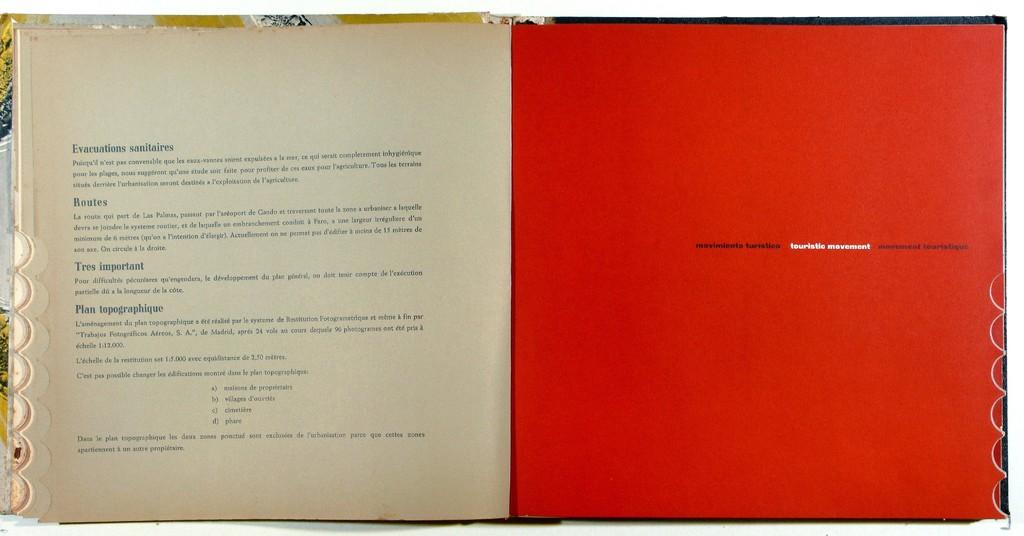<image>
Share a concise interpretation of the image provided. Moviemiento furisticoand touristic movement book about routes and evacuations sanitaries. 